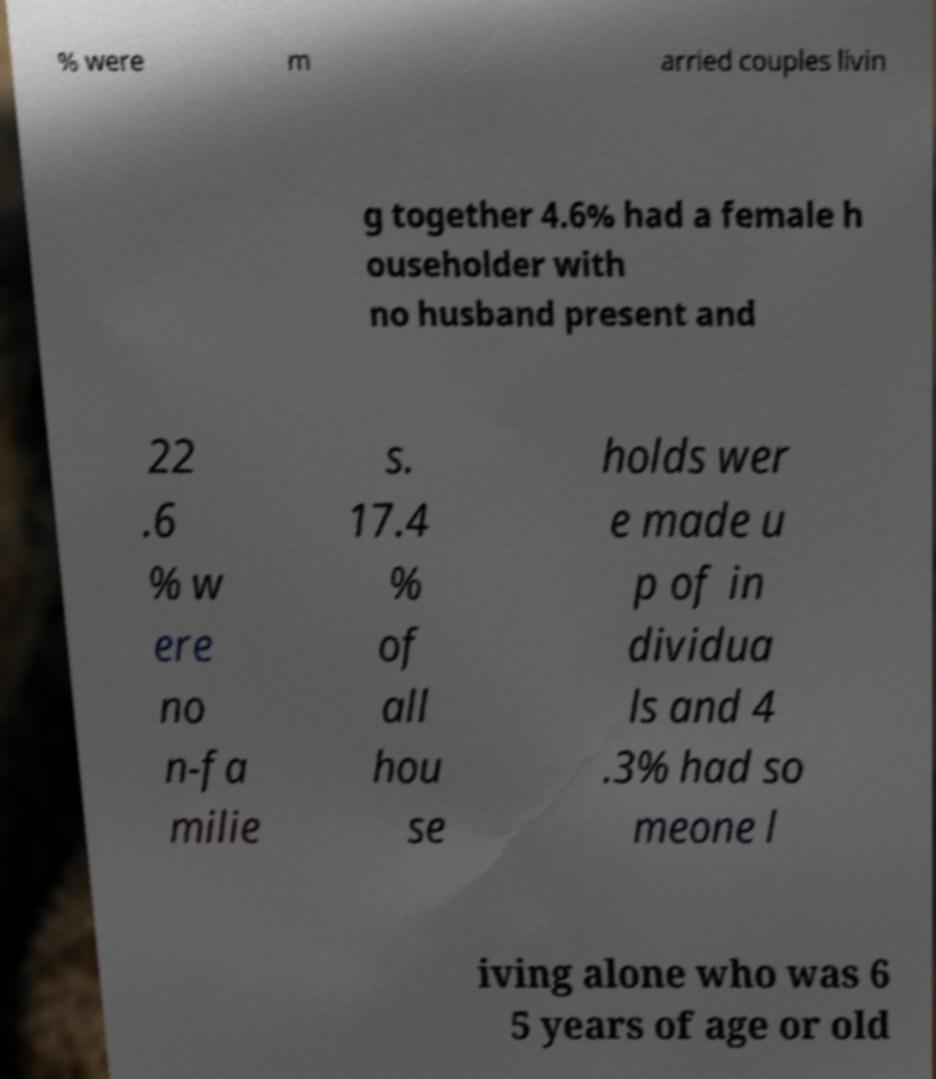I need the written content from this picture converted into text. Can you do that? % were m arried couples livin g together 4.6% had a female h ouseholder with no husband present and 22 .6 % w ere no n-fa milie s. 17.4 % of all hou se holds wer e made u p of in dividua ls and 4 .3% had so meone l iving alone who was 6 5 years of age or old 